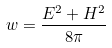Convert formula to latex. <formula><loc_0><loc_0><loc_500><loc_500>w = \frac { E ^ { 2 } + H ^ { 2 } } { 8 \pi }</formula> 